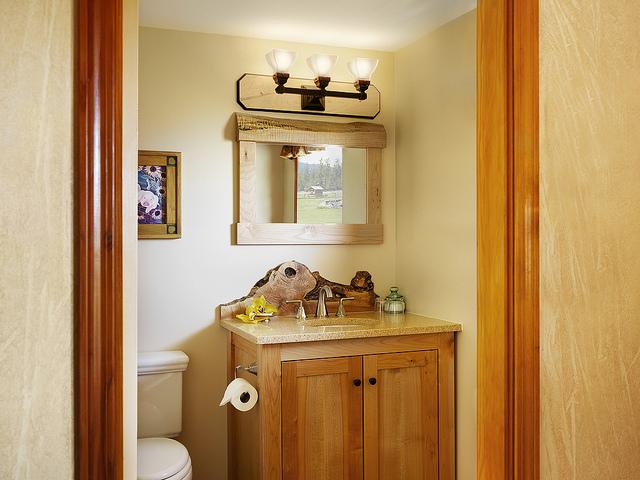Is the sink big?
Keep it brief. No. How many green items are on sink counter?
Give a very brief answer. 1. What color is the tissue?
Write a very short answer. White. 